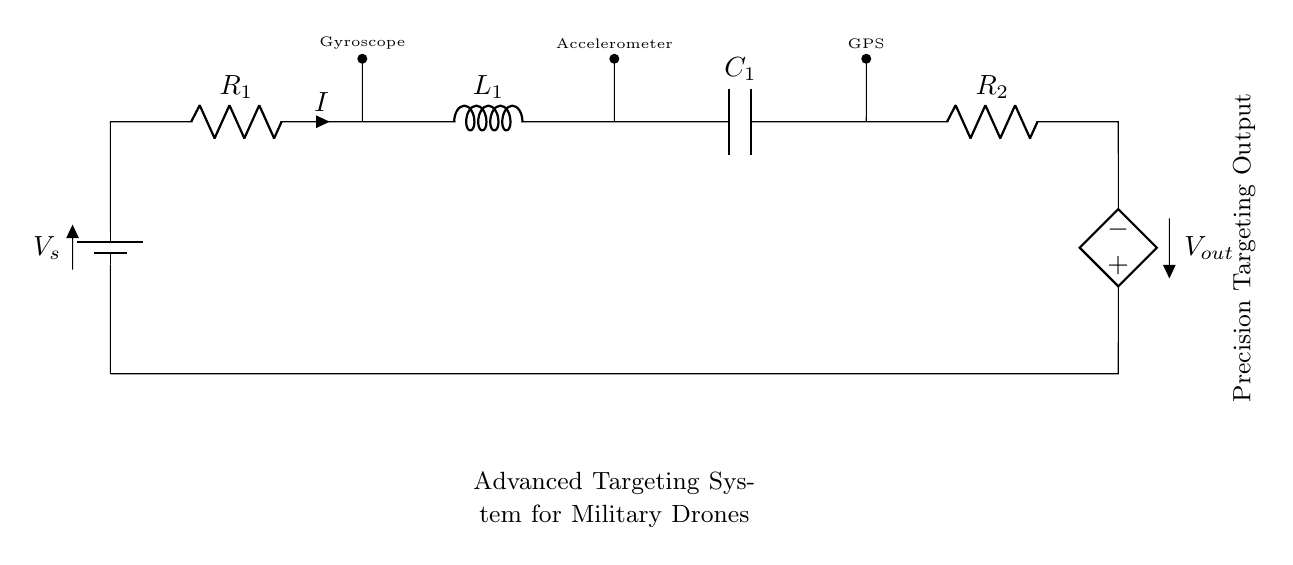What is the total number of components in the circuit? The circuit consists of five components: one battery, two resistors, one inductor, and one capacitor.
Answer: five components What does the output voltage source denote? The output voltage source, labeled as V out, indicates the precision targeting output generated by the circuit based on the inputs from the various sensors.
Answer: precision targeting output Which component is connected to the gyroscope? The component connected to the gyroscope is R one, which allows current I to flow through the circuit from the battery to the other components.
Answer: R one What type of filtering does the capacitor provide in this circuit? The capacitor serves as a smoothing or filtering component that helps reduce voltage fluctuations at the output, thereby ensuring stable performance of the targeting system.
Answer: smoothing What is the role of R two in this circuit? R two functions as a load resistor that helps control the output voltage level and contributes to the overall resistance in the circuit to manage current flow effectively.
Answer: load resistor How does the inductor contribute to the circuit's functionality? The inductor adds inductive reactance to the circuit, which is essential for managing the frequency response of the targeting system, allowing for more stable signal processing from the sensors.
Answer: inductive reactance What is the purpose of the accelerometer in this circuit? The accelerometer provides critical motion data, which is necessary for enhancing targeting accuracy and stabilizing the drone's flight during operations.
Answer: enhance targeting accuracy 